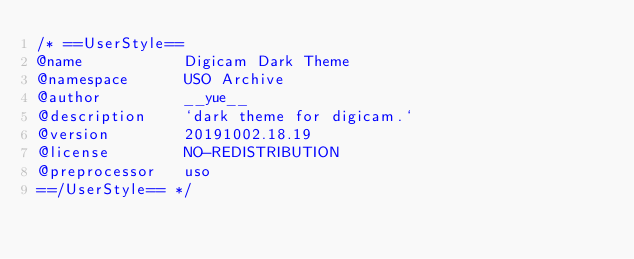Convert code to text. <code><loc_0><loc_0><loc_500><loc_500><_CSS_>/* ==UserStyle==
@name           Digicam Dark Theme
@namespace      USO Archive
@author         __yue__
@description    `dark theme for digicam.`
@version        20191002.18.19
@license        NO-REDISTRIBUTION
@preprocessor   uso
==/UserStyle== */</code> 